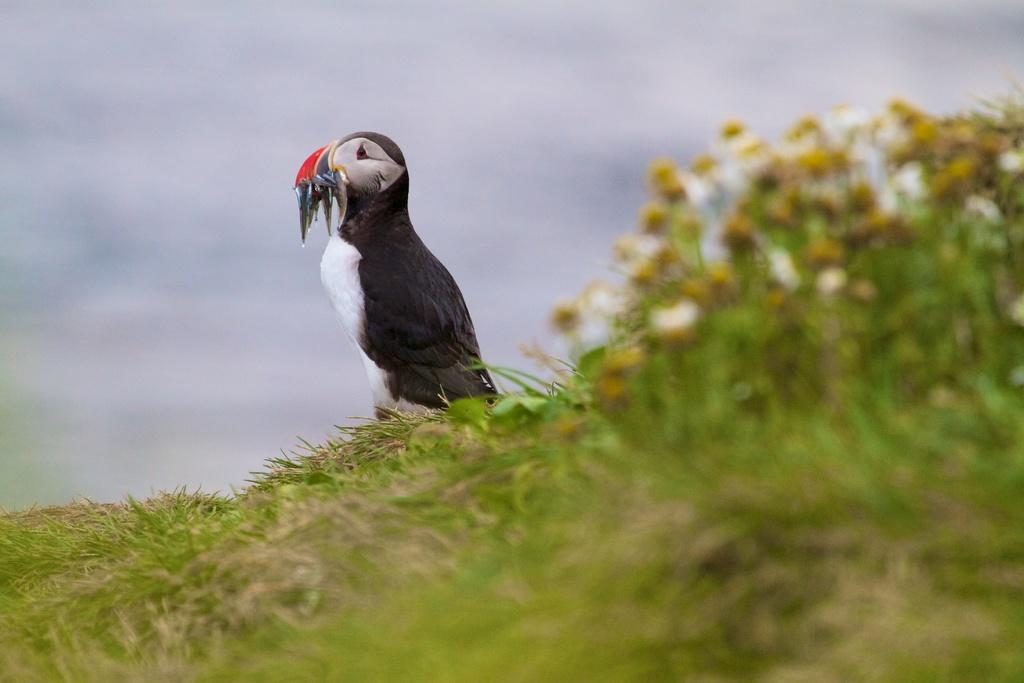What type of animal can be seen in the image? There is a bird in the image. What is located at the bottom of the image? There is grass at the bottom of the image. What type of vegetation is present in the image? There are plants with flowers in the image. What can be seen in the background of the image? The sky is visible in the background of the image. What kind of trouble is the bird causing in the image? There is no indication of trouble or any negative actions in the image; the bird is simply present. 